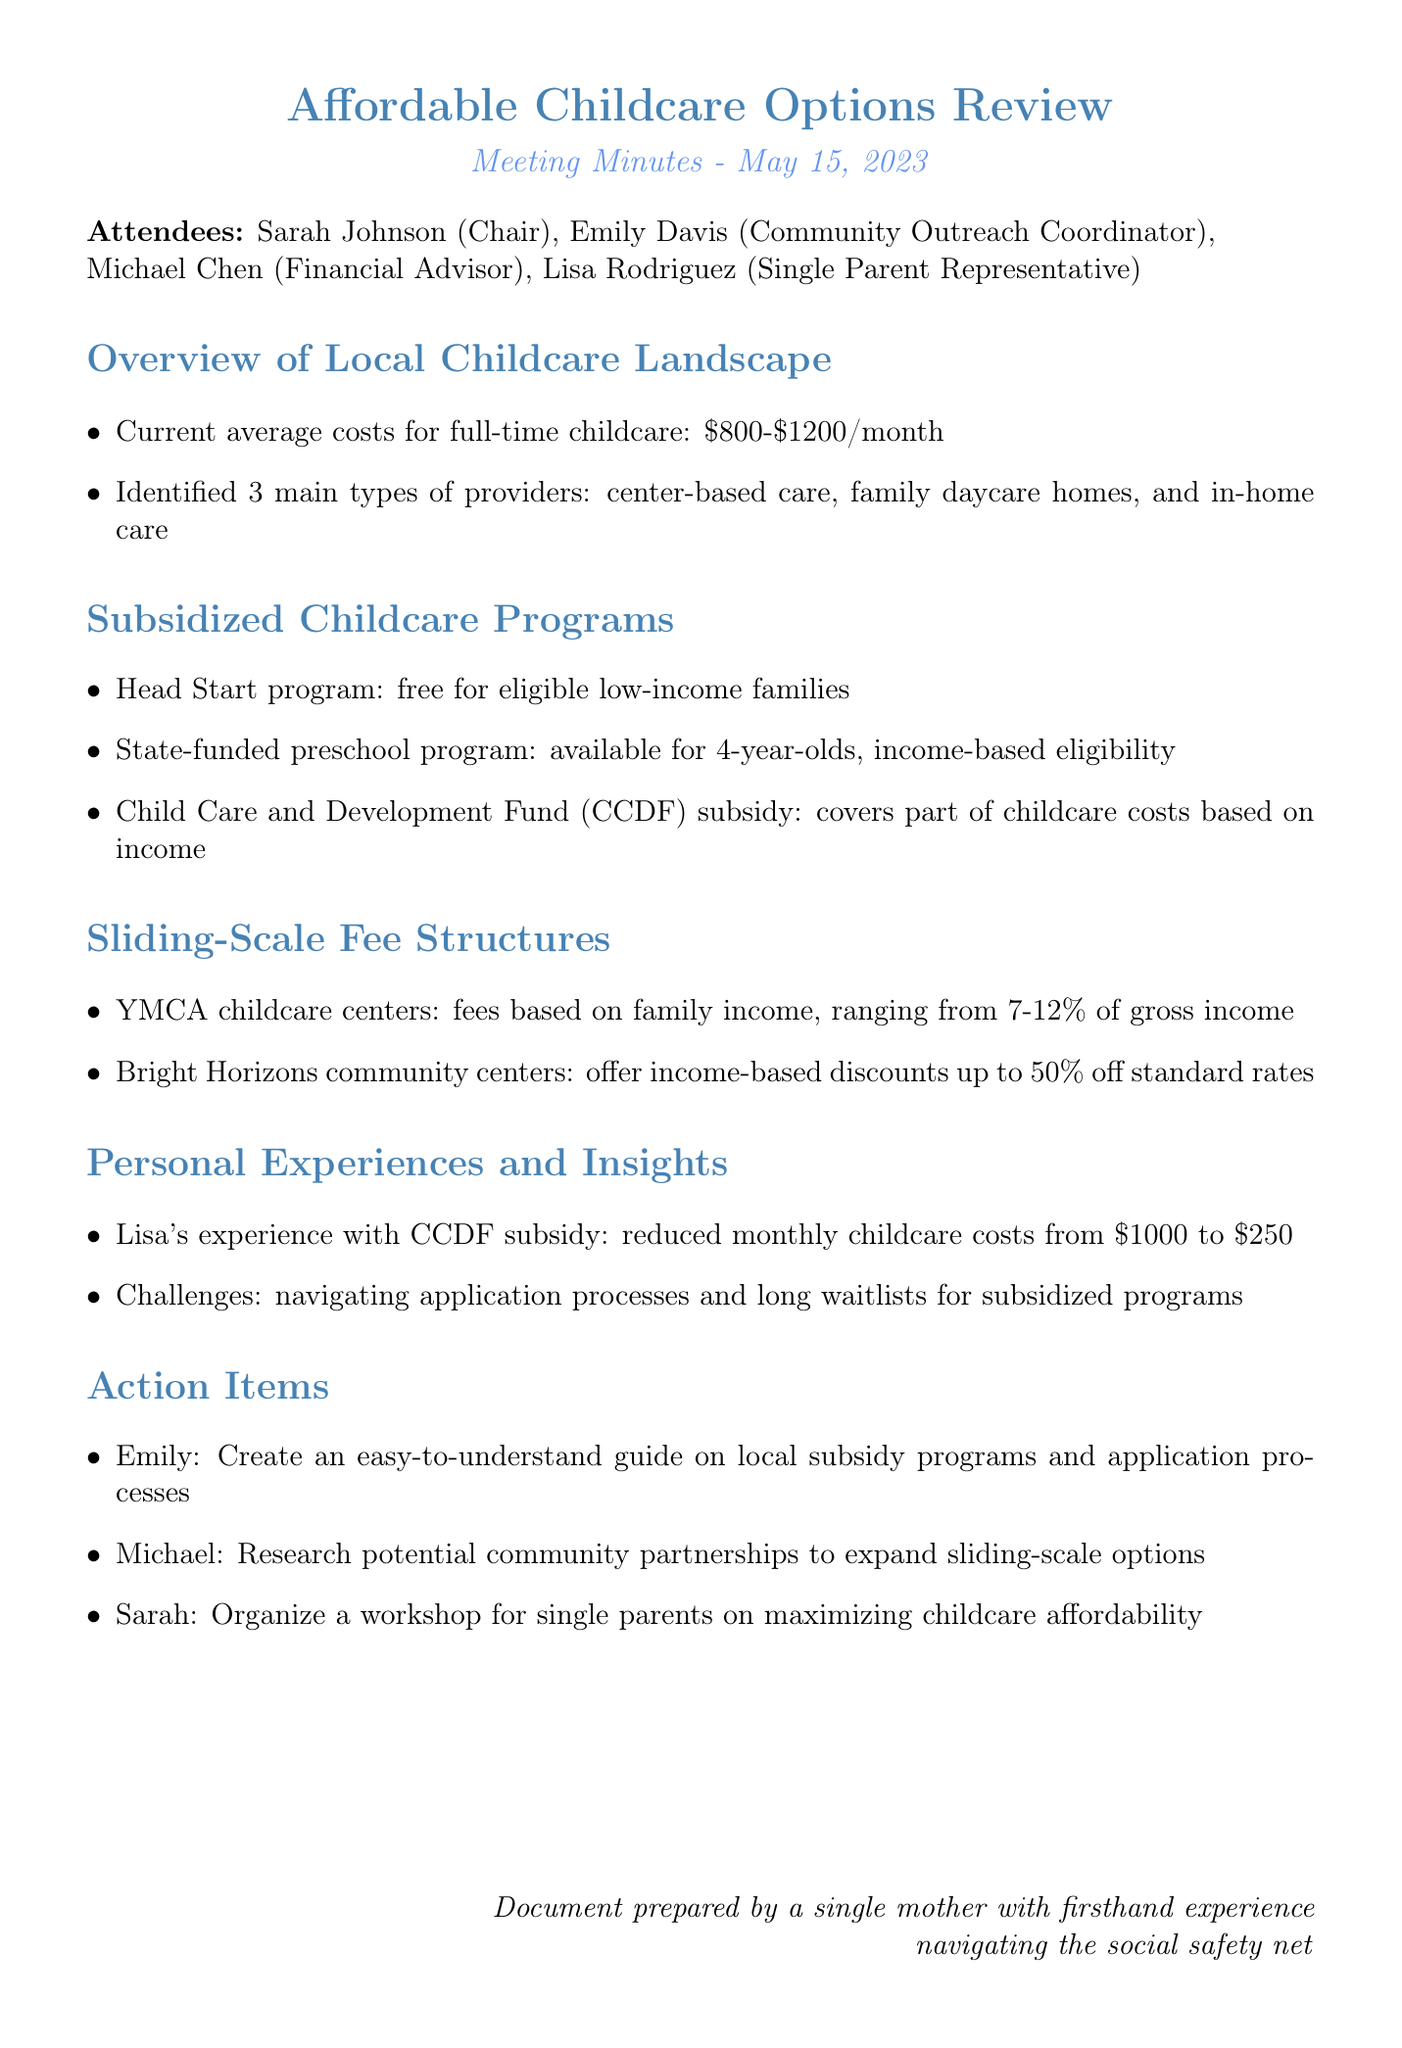What is the date of the meeting? The date of the meeting is stated in the document.
Answer: May 15, 2023 Who shared their experience with the CCDF subsidy? The document mentions a specific attendee who shared their experience.
Answer: Lisa How much do YMCA childcare centers charge based on family income? The document specifies the fee range for YMCA childcare centers.
Answer: 7-12% of gross income What is the maximum discount offered by Bright Horizons community centers? The document provides the percentage of discounts available at Bright Horizons.
Answer: 50% off What is the average cost range for full-time childcare in the area? The document includes the stated range for average costs.
Answer: $800-$1200/month What action item involves creating a guide on local subsidy programs? The document lists specific actions assigned to different attendees, one of which involves a guide.
Answer: Emily What type of childcare program is free for eligible low-income families? The document mentions a specific program that is free for low-income families.
Answer: Head Start program What challenge was discussed regarding subsidized programs? The document notes a specific challenge faced by individuals regarding programs.
Answer: Long waitlists 